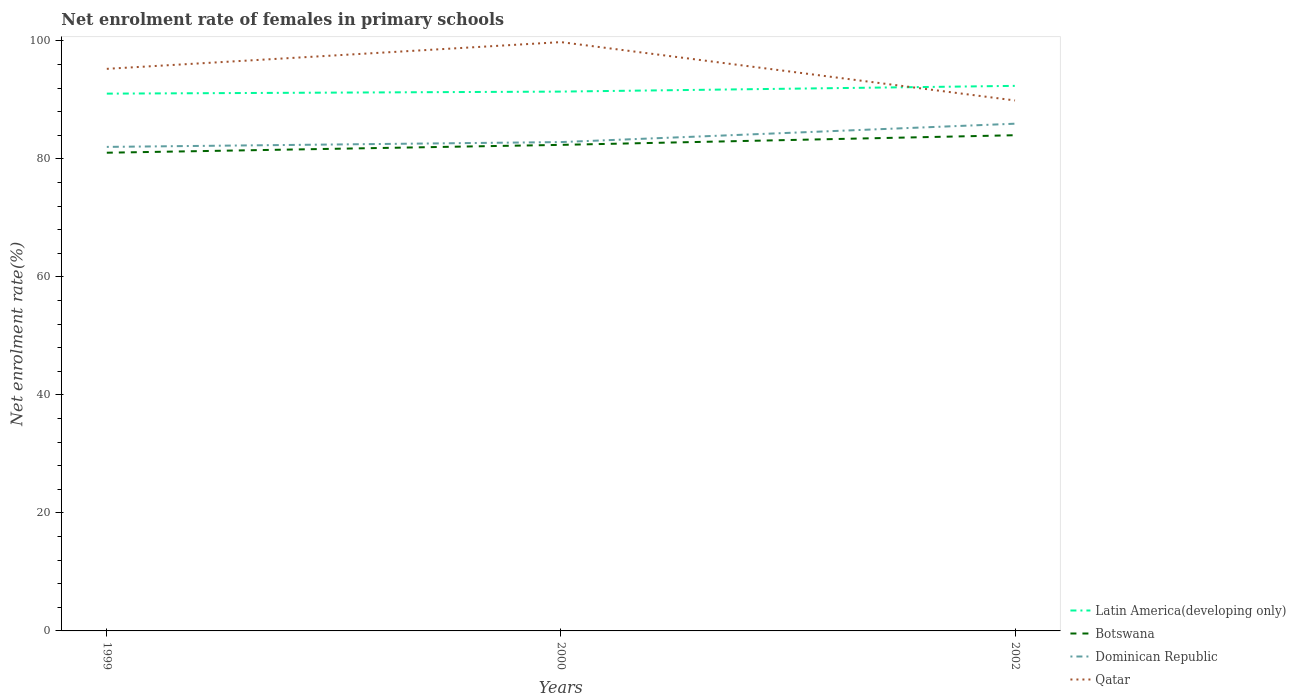How many different coloured lines are there?
Offer a very short reply. 4. Is the number of lines equal to the number of legend labels?
Make the answer very short. Yes. Across all years, what is the maximum net enrolment rate of females in primary schools in Dominican Republic?
Make the answer very short. 82.03. In which year was the net enrolment rate of females in primary schools in Qatar maximum?
Your answer should be very brief. 2002. What is the total net enrolment rate of females in primary schools in Botswana in the graph?
Make the answer very short. -1.33. What is the difference between the highest and the second highest net enrolment rate of females in primary schools in Qatar?
Provide a short and direct response. 9.89. What is the difference between the highest and the lowest net enrolment rate of females in primary schools in Latin America(developing only)?
Offer a very short reply. 1. How many years are there in the graph?
Keep it short and to the point. 3. Does the graph contain any zero values?
Your response must be concise. No. How many legend labels are there?
Provide a short and direct response. 4. How are the legend labels stacked?
Provide a short and direct response. Vertical. What is the title of the graph?
Your answer should be compact. Net enrolment rate of females in primary schools. Does "India" appear as one of the legend labels in the graph?
Make the answer very short. No. What is the label or title of the X-axis?
Your response must be concise. Years. What is the label or title of the Y-axis?
Make the answer very short. Net enrolment rate(%). What is the Net enrolment rate(%) in Latin America(developing only) in 1999?
Your answer should be compact. 91.06. What is the Net enrolment rate(%) in Botswana in 1999?
Provide a short and direct response. 81.05. What is the Net enrolment rate(%) of Dominican Republic in 1999?
Give a very brief answer. 82.03. What is the Net enrolment rate(%) of Qatar in 1999?
Your answer should be very brief. 95.26. What is the Net enrolment rate(%) in Latin America(developing only) in 2000?
Offer a very short reply. 91.41. What is the Net enrolment rate(%) in Botswana in 2000?
Give a very brief answer. 82.38. What is the Net enrolment rate(%) of Dominican Republic in 2000?
Your answer should be very brief. 82.85. What is the Net enrolment rate(%) of Qatar in 2000?
Offer a terse response. 99.79. What is the Net enrolment rate(%) of Latin America(developing only) in 2002?
Make the answer very short. 92.38. What is the Net enrolment rate(%) of Botswana in 2002?
Give a very brief answer. 84.01. What is the Net enrolment rate(%) in Dominican Republic in 2002?
Make the answer very short. 85.96. What is the Net enrolment rate(%) in Qatar in 2002?
Make the answer very short. 89.9. Across all years, what is the maximum Net enrolment rate(%) in Latin America(developing only)?
Your answer should be compact. 92.38. Across all years, what is the maximum Net enrolment rate(%) in Botswana?
Ensure brevity in your answer.  84.01. Across all years, what is the maximum Net enrolment rate(%) of Dominican Republic?
Offer a very short reply. 85.96. Across all years, what is the maximum Net enrolment rate(%) in Qatar?
Your response must be concise. 99.79. Across all years, what is the minimum Net enrolment rate(%) in Latin America(developing only)?
Your answer should be very brief. 91.06. Across all years, what is the minimum Net enrolment rate(%) in Botswana?
Offer a very short reply. 81.05. Across all years, what is the minimum Net enrolment rate(%) of Dominican Republic?
Ensure brevity in your answer.  82.03. Across all years, what is the minimum Net enrolment rate(%) in Qatar?
Keep it short and to the point. 89.9. What is the total Net enrolment rate(%) in Latin America(developing only) in the graph?
Your answer should be compact. 274.84. What is the total Net enrolment rate(%) of Botswana in the graph?
Your response must be concise. 247.43. What is the total Net enrolment rate(%) in Dominican Republic in the graph?
Provide a short and direct response. 250.85. What is the total Net enrolment rate(%) in Qatar in the graph?
Provide a short and direct response. 284.96. What is the difference between the Net enrolment rate(%) of Latin America(developing only) in 1999 and that in 2000?
Give a very brief answer. -0.34. What is the difference between the Net enrolment rate(%) in Botswana in 1999 and that in 2000?
Offer a terse response. -1.33. What is the difference between the Net enrolment rate(%) in Dominican Republic in 1999 and that in 2000?
Ensure brevity in your answer.  -0.82. What is the difference between the Net enrolment rate(%) of Qatar in 1999 and that in 2000?
Give a very brief answer. -4.53. What is the difference between the Net enrolment rate(%) in Latin America(developing only) in 1999 and that in 2002?
Provide a succinct answer. -1.32. What is the difference between the Net enrolment rate(%) of Botswana in 1999 and that in 2002?
Offer a terse response. -2.97. What is the difference between the Net enrolment rate(%) of Dominican Republic in 1999 and that in 2002?
Provide a short and direct response. -3.93. What is the difference between the Net enrolment rate(%) of Qatar in 1999 and that in 2002?
Give a very brief answer. 5.36. What is the difference between the Net enrolment rate(%) in Latin America(developing only) in 2000 and that in 2002?
Provide a short and direct response. -0.97. What is the difference between the Net enrolment rate(%) in Botswana in 2000 and that in 2002?
Offer a very short reply. -1.64. What is the difference between the Net enrolment rate(%) of Dominican Republic in 2000 and that in 2002?
Offer a very short reply. -3.12. What is the difference between the Net enrolment rate(%) in Qatar in 2000 and that in 2002?
Provide a succinct answer. 9.89. What is the difference between the Net enrolment rate(%) in Latin America(developing only) in 1999 and the Net enrolment rate(%) in Botswana in 2000?
Offer a very short reply. 8.68. What is the difference between the Net enrolment rate(%) in Latin America(developing only) in 1999 and the Net enrolment rate(%) in Dominican Republic in 2000?
Provide a succinct answer. 8.21. What is the difference between the Net enrolment rate(%) of Latin America(developing only) in 1999 and the Net enrolment rate(%) of Qatar in 2000?
Your answer should be very brief. -8.73. What is the difference between the Net enrolment rate(%) of Botswana in 1999 and the Net enrolment rate(%) of Dominican Republic in 2000?
Your response must be concise. -1.8. What is the difference between the Net enrolment rate(%) of Botswana in 1999 and the Net enrolment rate(%) of Qatar in 2000?
Keep it short and to the point. -18.75. What is the difference between the Net enrolment rate(%) of Dominican Republic in 1999 and the Net enrolment rate(%) of Qatar in 2000?
Give a very brief answer. -17.76. What is the difference between the Net enrolment rate(%) of Latin America(developing only) in 1999 and the Net enrolment rate(%) of Botswana in 2002?
Your response must be concise. 7.05. What is the difference between the Net enrolment rate(%) in Latin America(developing only) in 1999 and the Net enrolment rate(%) in Dominican Republic in 2002?
Provide a short and direct response. 5.1. What is the difference between the Net enrolment rate(%) of Latin America(developing only) in 1999 and the Net enrolment rate(%) of Qatar in 2002?
Provide a succinct answer. 1.16. What is the difference between the Net enrolment rate(%) in Botswana in 1999 and the Net enrolment rate(%) in Dominican Republic in 2002?
Keep it short and to the point. -4.92. What is the difference between the Net enrolment rate(%) in Botswana in 1999 and the Net enrolment rate(%) in Qatar in 2002?
Your response must be concise. -8.86. What is the difference between the Net enrolment rate(%) in Dominican Republic in 1999 and the Net enrolment rate(%) in Qatar in 2002?
Provide a short and direct response. -7.87. What is the difference between the Net enrolment rate(%) of Latin America(developing only) in 2000 and the Net enrolment rate(%) of Botswana in 2002?
Ensure brevity in your answer.  7.39. What is the difference between the Net enrolment rate(%) of Latin America(developing only) in 2000 and the Net enrolment rate(%) of Dominican Republic in 2002?
Provide a succinct answer. 5.44. What is the difference between the Net enrolment rate(%) of Latin America(developing only) in 2000 and the Net enrolment rate(%) of Qatar in 2002?
Make the answer very short. 1.5. What is the difference between the Net enrolment rate(%) of Botswana in 2000 and the Net enrolment rate(%) of Dominican Republic in 2002?
Keep it short and to the point. -3.59. What is the difference between the Net enrolment rate(%) of Botswana in 2000 and the Net enrolment rate(%) of Qatar in 2002?
Keep it short and to the point. -7.53. What is the difference between the Net enrolment rate(%) in Dominican Republic in 2000 and the Net enrolment rate(%) in Qatar in 2002?
Your answer should be compact. -7.05. What is the average Net enrolment rate(%) in Latin America(developing only) per year?
Keep it short and to the point. 91.61. What is the average Net enrolment rate(%) in Botswana per year?
Offer a terse response. 82.48. What is the average Net enrolment rate(%) of Dominican Republic per year?
Make the answer very short. 83.61. What is the average Net enrolment rate(%) in Qatar per year?
Provide a succinct answer. 94.99. In the year 1999, what is the difference between the Net enrolment rate(%) of Latin America(developing only) and Net enrolment rate(%) of Botswana?
Provide a succinct answer. 10.01. In the year 1999, what is the difference between the Net enrolment rate(%) in Latin America(developing only) and Net enrolment rate(%) in Dominican Republic?
Your response must be concise. 9.03. In the year 1999, what is the difference between the Net enrolment rate(%) in Latin America(developing only) and Net enrolment rate(%) in Qatar?
Your response must be concise. -4.2. In the year 1999, what is the difference between the Net enrolment rate(%) in Botswana and Net enrolment rate(%) in Dominican Republic?
Ensure brevity in your answer.  -0.99. In the year 1999, what is the difference between the Net enrolment rate(%) in Botswana and Net enrolment rate(%) in Qatar?
Offer a terse response. -14.22. In the year 1999, what is the difference between the Net enrolment rate(%) of Dominican Republic and Net enrolment rate(%) of Qatar?
Offer a terse response. -13.23. In the year 2000, what is the difference between the Net enrolment rate(%) in Latin America(developing only) and Net enrolment rate(%) in Botswana?
Your response must be concise. 9.03. In the year 2000, what is the difference between the Net enrolment rate(%) of Latin America(developing only) and Net enrolment rate(%) of Dominican Republic?
Provide a short and direct response. 8.56. In the year 2000, what is the difference between the Net enrolment rate(%) in Latin America(developing only) and Net enrolment rate(%) in Qatar?
Offer a very short reply. -8.39. In the year 2000, what is the difference between the Net enrolment rate(%) of Botswana and Net enrolment rate(%) of Dominican Republic?
Offer a terse response. -0.47. In the year 2000, what is the difference between the Net enrolment rate(%) of Botswana and Net enrolment rate(%) of Qatar?
Keep it short and to the point. -17.42. In the year 2000, what is the difference between the Net enrolment rate(%) in Dominican Republic and Net enrolment rate(%) in Qatar?
Your answer should be very brief. -16.94. In the year 2002, what is the difference between the Net enrolment rate(%) of Latin America(developing only) and Net enrolment rate(%) of Botswana?
Your response must be concise. 8.36. In the year 2002, what is the difference between the Net enrolment rate(%) in Latin America(developing only) and Net enrolment rate(%) in Dominican Republic?
Give a very brief answer. 6.41. In the year 2002, what is the difference between the Net enrolment rate(%) of Latin America(developing only) and Net enrolment rate(%) of Qatar?
Your answer should be very brief. 2.47. In the year 2002, what is the difference between the Net enrolment rate(%) of Botswana and Net enrolment rate(%) of Dominican Republic?
Provide a short and direct response. -1.95. In the year 2002, what is the difference between the Net enrolment rate(%) in Botswana and Net enrolment rate(%) in Qatar?
Offer a very short reply. -5.89. In the year 2002, what is the difference between the Net enrolment rate(%) in Dominican Republic and Net enrolment rate(%) in Qatar?
Offer a very short reply. -3.94. What is the ratio of the Net enrolment rate(%) in Latin America(developing only) in 1999 to that in 2000?
Your answer should be very brief. 1. What is the ratio of the Net enrolment rate(%) of Botswana in 1999 to that in 2000?
Your answer should be compact. 0.98. What is the ratio of the Net enrolment rate(%) of Dominican Republic in 1999 to that in 2000?
Your answer should be very brief. 0.99. What is the ratio of the Net enrolment rate(%) in Qatar in 1999 to that in 2000?
Provide a succinct answer. 0.95. What is the ratio of the Net enrolment rate(%) in Latin America(developing only) in 1999 to that in 2002?
Your response must be concise. 0.99. What is the ratio of the Net enrolment rate(%) in Botswana in 1999 to that in 2002?
Provide a short and direct response. 0.96. What is the ratio of the Net enrolment rate(%) of Dominican Republic in 1999 to that in 2002?
Your answer should be compact. 0.95. What is the ratio of the Net enrolment rate(%) in Qatar in 1999 to that in 2002?
Your answer should be compact. 1.06. What is the ratio of the Net enrolment rate(%) of Botswana in 2000 to that in 2002?
Make the answer very short. 0.98. What is the ratio of the Net enrolment rate(%) in Dominican Republic in 2000 to that in 2002?
Your answer should be very brief. 0.96. What is the ratio of the Net enrolment rate(%) in Qatar in 2000 to that in 2002?
Make the answer very short. 1.11. What is the difference between the highest and the second highest Net enrolment rate(%) in Latin America(developing only)?
Your answer should be compact. 0.97. What is the difference between the highest and the second highest Net enrolment rate(%) of Botswana?
Give a very brief answer. 1.64. What is the difference between the highest and the second highest Net enrolment rate(%) of Dominican Republic?
Your response must be concise. 3.12. What is the difference between the highest and the second highest Net enrolment rate(%) in Qatar?
Offer a terse response. 4.53. What is the difference between the highest and the lowest Net enrolment rate(%) in Latin America(developing only)?
Make the answer very short. 1.32. What is the difference between the highest and the lowest Net enrolment rate(%) of Botswana?
Your answer should be very brief. 2.97. What is the difference between the highest and the lowest Net enrolment rate(%) of Dominican Republic?
Your answer should be very brief. 3.93. What is the difference between the highest and the lowest Net enrolment rate(%) in Qatar?
Your answer should be compact. 9.89. 